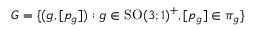<formula> <loc_0><loc_0><loc_500><loc_500>G = \{ ( g , [ p _ { g } ] ) \colon g \in S O ( 3 ; 1 ) ^ { + } , [ p _ { g } ] \in \pi _ { g } \}</formula> 